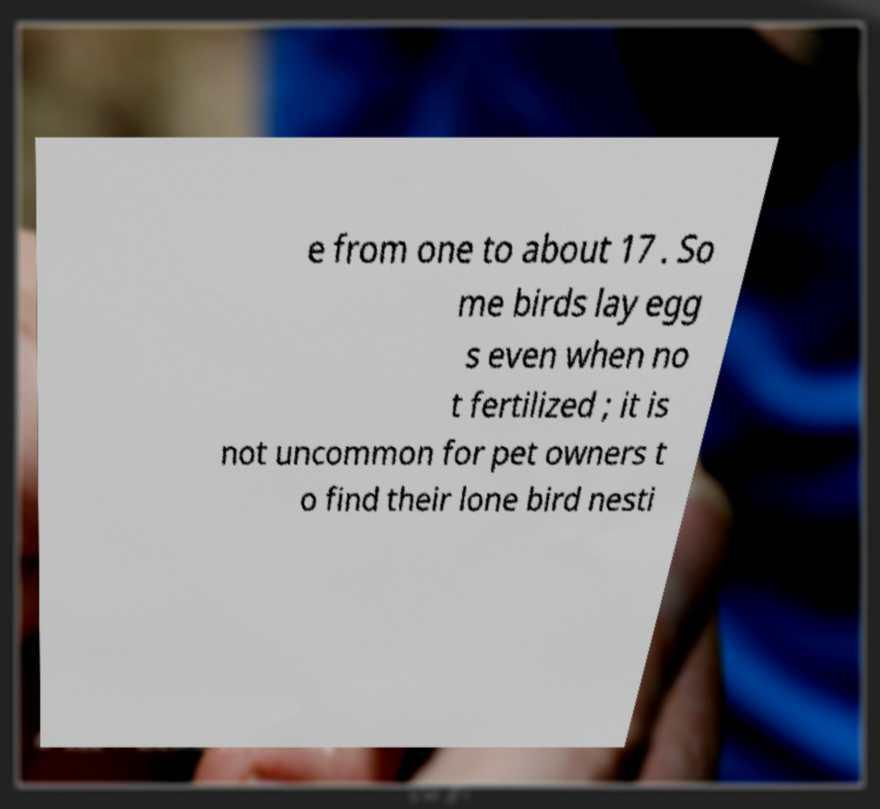I need the written content from this picture converted into text. Can you do that? e from one to about 17 . So me birds lay egg s even when no t fertilized ; it is not uncommon for pet owners t o find their lone bird nesti 